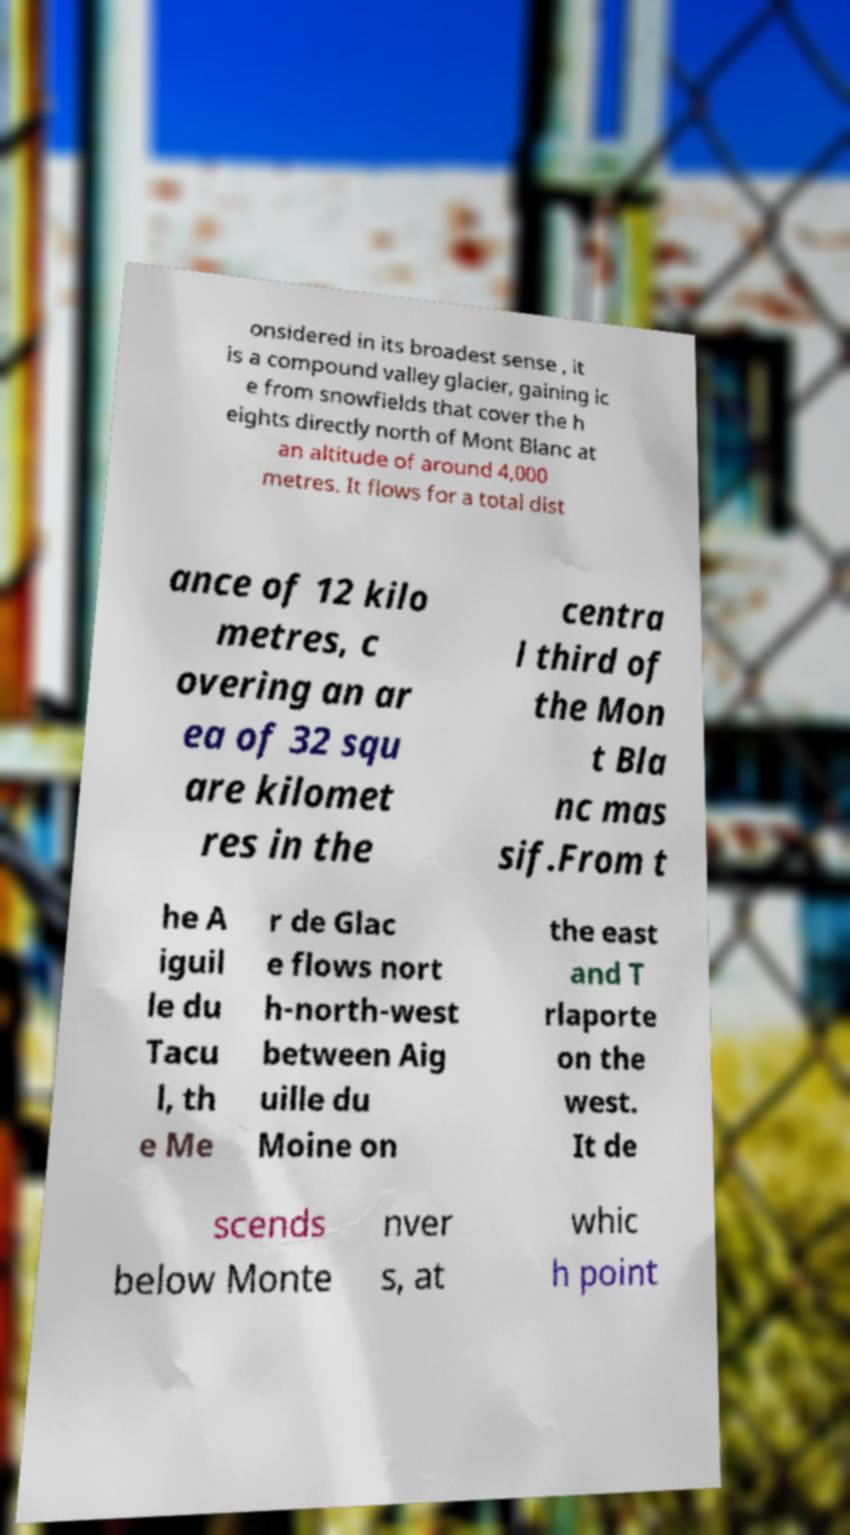Can you read and provide the text displayed in the image?This photo seems to have some interesting text. Can you extract and type it out for me? onsidered in its broadest sense , it is a compound valley glacier, gaining ic e from snowfields that cover the h eights directly north of Mont Blanc at an altitude of around 4,000 metres. It flows for a total dist ance of 12 kilo metres, c overing an ar ea of 32 squ are kilomet res in the centra l third of the Mon t Bla nc mas sif.From t he A iguil le du Tacu l, th e Me r de Glac e flows nort h-north-west between Aig uille du Moine on the east and T rlaporte on the west. It de scends below Monte nver s, at whic h point 